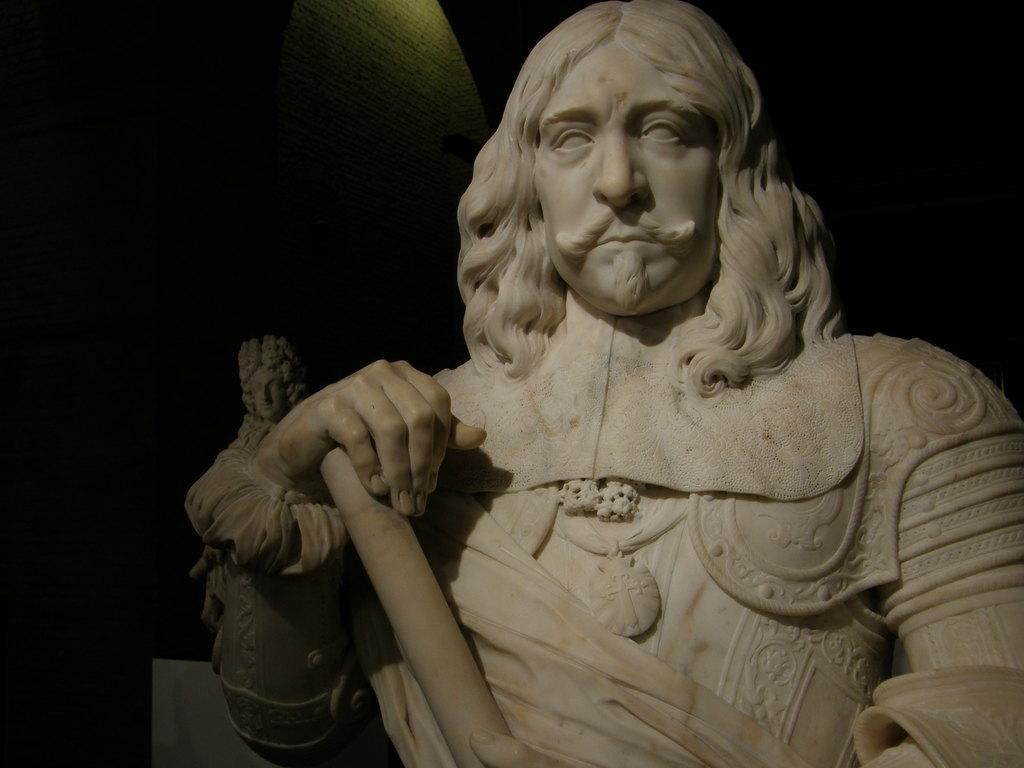What is the main subject in the center of the image? There are statues in the center of the image. What type of drug is being used by the statues in the image? There is no drug use depicted in the image; it features statues in the center. How are the statues maintaining their balance in the image? The statues are not shown to be balancing or performing any actions in the image. 